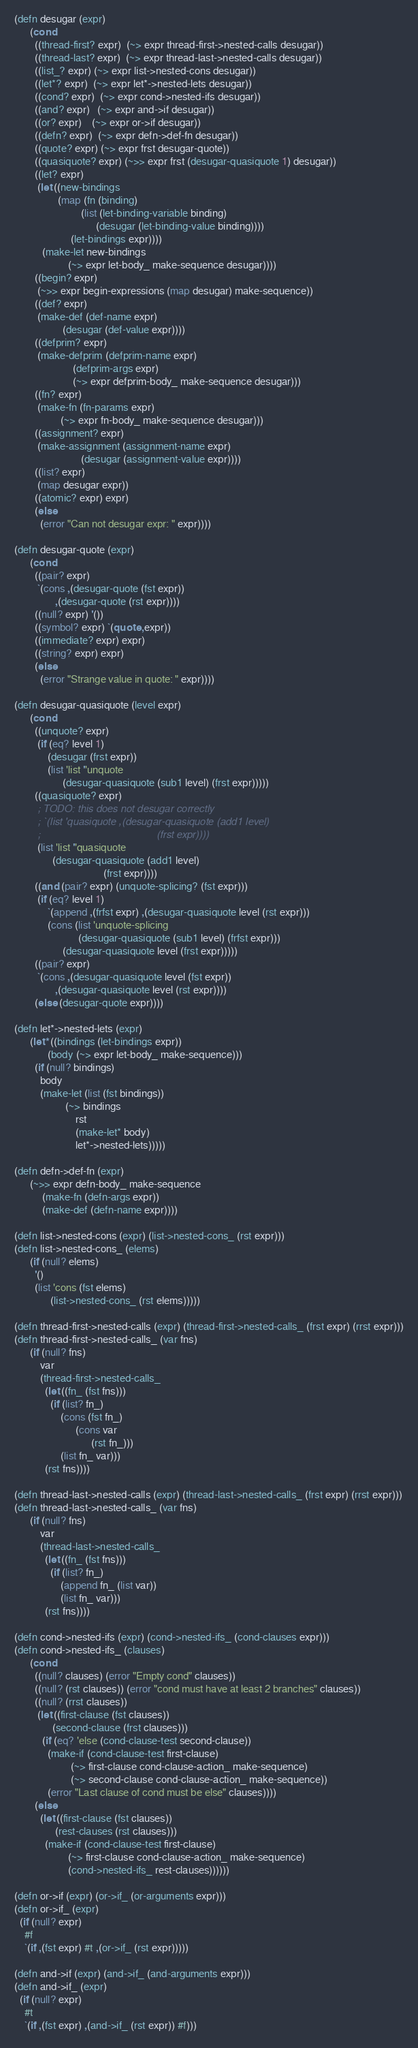Convert code to text. <code><loc_0><loc_0><loc_500><loc_500><_Scheme_>(defn desugar (expr)
      (cond
        ((thread-first? expr)  (~> expr thread-first->nested-calls desugar))
        ((thread-last? expr)  (~> expr thread-last->nested-calls desugar))
        ((list_? expr) (~> expr list->nested-cons desugar))
        ((let*? expr)  (~> expr let*->nested-lets desugar))
        ((cond? expr)  (~> expr cond->nested-ifs desugar))
        ((and? expr)   (~> expr and->if desugar))
        ((or? expr)    (~> expr or->if desugar))
        ((defn? expr)  (~> expr defn->def-fn desugar))
        ((quote? expr) (~> expr frst desugar-quote))
        ((quasiquote? expr) (~>> expr frst (desugar-quasiquote 1) desugar))
        ((let? expr)
         (let ((new-bindings
                 (map (fn (binding)
                          (list (let-binding-variable binding)
                                (desugar (let-binding-value binding))))
                      (let-bindings expr))))
           (make-let new-bindings
                     (~> expr let-body_ make-sequence desugar))))
        ((begin? expr)
         (~>> expr begin-expressions (map desugar) make-sequence))
        ((def? expr)
         (make-def (def-name expr)
                   (desugar (def-value expr))))
        ((defprim? expr)
         (make-defprim (defprim-name expr)
                       (defprim-args expr)
                       (~> expr defprim-body_ make-sequence desugar)))
        ((fn? expr)
         (make-fn (fn-params expr)
                  (~> expr fn-body_ make-sequence desugar)))
        ((assignment? expr)
         (make-assignment (assignment-name expr)
                          (desugar (assignment-value expr))))
        ((list? expr)
         (map desugar expr))
        ((atomic? expr) expr)
        (else
          (error "Can not desugar expr: " expr))))

(defn desugar-quote (expr)
      (cond
        ((pair? expr)
         `(cons ,(desugar-quote (fst expr))
                ,(desugar-quote (rst expr))))
        ((null? expr) '())
        ((symbol? expr) `(quote ,expr))
        ((immediate? expr) expr)
        ((string? expr) expr)
        (else
          (error "Strange value in quote: " expr))))

(defn desugar-quasiquote (level expr)
      (cond
        ((unquote? expr)
         (if (eq? level 1)
             (desugar (frst expr))
             (list 'list ''unquote
                   (desugar-quasiquote (sub1 level) (frst expr)))))
        ((quasiquote? expr)
         ; TODO: this does not desugar correctly
         ; `(list 'quasiquote ,(desugar-quasiquote (add1 level)
         ;                                         (frst expr))))
         (list 'list ''quasiquote
               (desugar-quasiquote (add1 level)
                                   (frst expr))))
        ((and (pair? expr) (unquote-splicing? (fst expr)))
         (if (eq? level 1)
             `(append ,(frfst expr) ,(desugar-quasiquote level (rst expr)))
             (cons (list 'unquote-splicing
                         (desugar-quasiquote (sub1 level) (frfst expr)))
                   (desugar-quasiquote level (frst expr)))))
        ((pair? expr)
         `(cons ,(desugar-quasiquote level (fst expr))
                ,(desugar-quasiquote level (rst expr))))
        (else (desugar-quote expr))))

(defn let*->nested-lets (expr)
      (let* ((bindings (let-bindings expr))
             (body (~> expr let-body_ make-sequence)))
        (if (null? bindings)
          body
          (make-let (list (fst bindings))
                    (~> bindings
                        rst
                        (make-let* body)
                        let*->nested-lets)))))

(defn defn->def-fn (expr)
      (~>> expr defn-body_ make-sequence
           (make-fn (defn-args expr))
           (make-def (defn-name expr))))

(defn list->nested-cons (expr) (list->nested-cons_ (rst expr)))
(defn list->nested-cons_ (elems)
      (if (null? elems)
        '()
        (list 'cons (fst elems)
              (list->nested-cons_ (rst elems)))))

(defn thread-first->nested-calls (expr) (thread-first->nested-calls_ (frst expr) (rrst expr)))
(defn thread-first->nested-calls_ (var fns)
      (if (null? fns)
          var
          (thread-first->nested-calls_
            (let ((fn_ (fst fns)))
              (if (list? fn_)
                  (cons (fst fn_)
                        (cons var
                              (rst fn_)))
                  (list fn_ var)))
            (rst fns))))

(defn thread-last->nested-calls (expr) (thread-last->nested-calls_ (frst expr) (rrst expr)))
(defn thread-last->nested-calls_ (var fns)
      (if (null? fns)
          var
          (thread-last->nested-calls_
            (let ((fn_ (fst fns)))
              (if (list? fn_)
                  (append fn_ (list var))
                  (list fn_ var)))
            (rst fns))))

(defn cond->nested-ifs (expr) (cond->nested-ifs_ (cond-clauses expr)))
(defn cond->nested-ifs_ (clauses)
      (cond
        ((null? clauses) (error "Empty cond" clauses))
        ((null? (rst clauses)) (error "cond must have at least 2 branches" clauses))
        ((null? (rrst clauses))
         (let ((first-clause (fst clauses))
               (second-clause (frst clauses)))
           (if (eq? 'else (cond-clause-test second-clause))
             (make-if (cond-clause-test first-clause)
                      (~> first-clause cond-clause-action_ make-sequence)
                      (~> second-clause cond-clause-action_ make-sequence))
             (error "Last clause of cond must be else" clauses))))
        (else
          (let ((first-clause (fst clauses))
                (rest-clauses (rst clauses)))
            (make-if (cond-clause-test first-clause)
                     (~> first-clause cond-clause-action_ make-sequence)
                     (cond->nested-ifs_ rest-clauses))))))

(defn or->if (expr) (or->if_ (or-arguments expr)))
(defn or->if_ (expr)
  (if (null? expr)
    #f
    `(if ,(fst expr) #t ,(or->if_ (rst expr)))))

(defn and->if (expr) (and->if_ (and-arguments expr)))
(defn and->if_ (expr)
  (if (null? expr)
    #t
    `(if ,(fst expr) ,(and->if_ (rst expr)) #f)))
</code> 